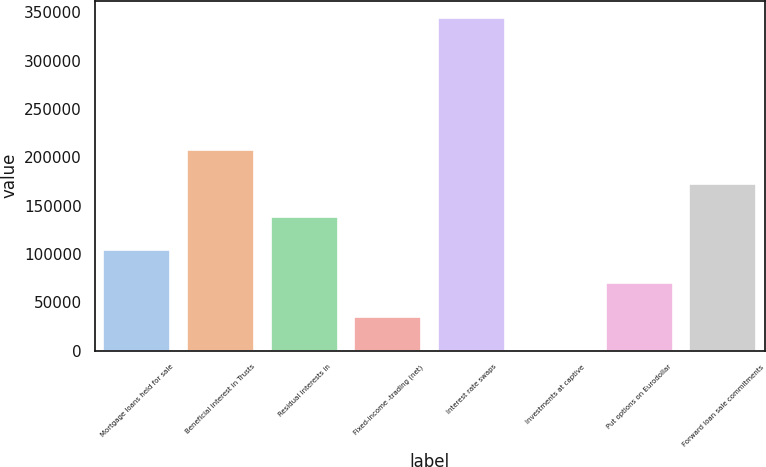<chart> <loc_0><loc_0><loc_500><loc_500><bar_chart><fcel>Mortgage loans held for sale<fcel>Beneficial interest in Trusts<fcel>Residual interests in<fcel>Fixed-income -trading (net)<fcel>Interest rate swaps<fcel>Investments at captive<fcel>Put options on Eurodollar<fcel>Forward loan sale commitments<nl><fcel>103952<fcel>207089<fcel>138331<fcel>35193.2<fcel>344606<fcel>814<fcel>69572.4<fcel>172710<nl></chart> 